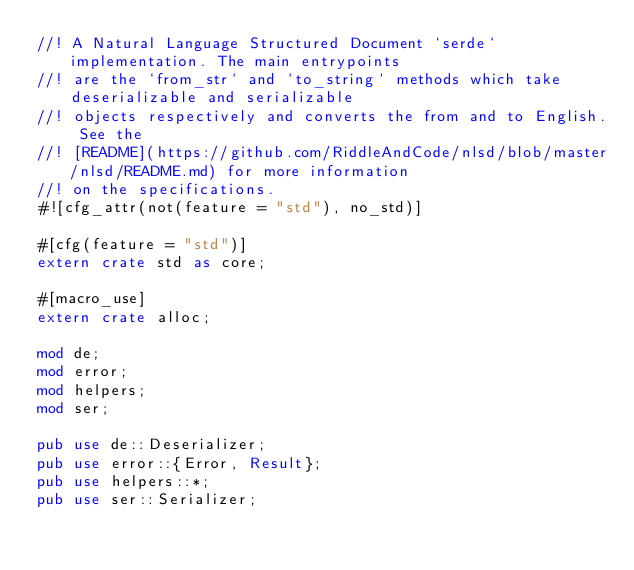<code> <loc_0><loc_0><loc_500><loc_500><_Rust_>//! A Natural Language Structured Document `serde` implementation. The main entrypoints
//! are the `from_str` and `to_string` methods which take deserializable and serializable
//! objects respectively and converts the from and to English. See the
//! [README](https://github.com/RiddleAndCode/nlsd/blob/master/nlsd/README.md) for more information
//! on the specifications.
#![cfg_attr(not(feature = "std"), no_std)]

#[cfg(feature = "std")]
extern crate std as core;

#[macro_use]
extern crate alloc;

mod de;
mod error;
mod helpers;
mod ser;

pub use de::Deserializer;
pub use error::{Error, Result};
pub use helpers::*;
pub use ser::Serializer;
</code> 